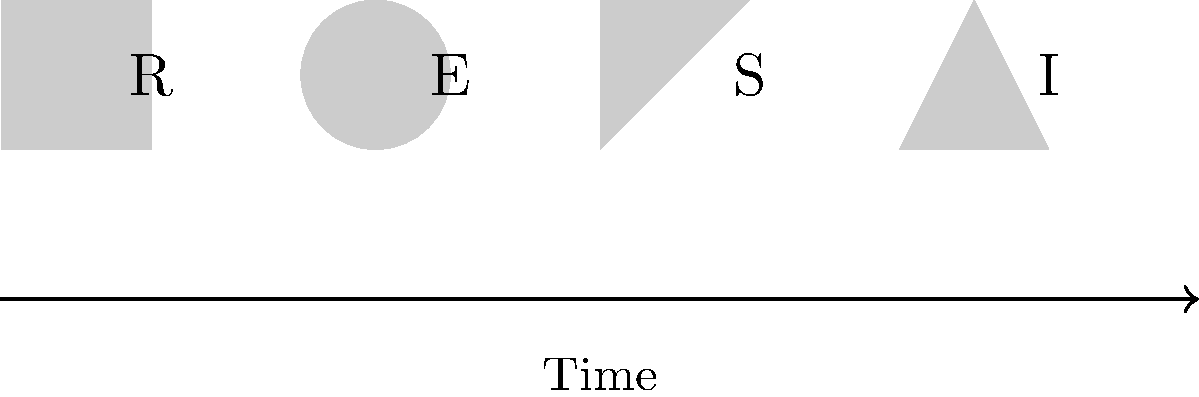Decode the secret message hidden in the sequence of symbols. What word does it spell? To decode the secret message, follow these steps:

1. Observe the sequence of symbols from left to right.
2. Each symbol corresponds to a letter shown below it.
3. The symbols represent:
   - Square: R
   - Circle: E
   - Triangle: S
   - Diamond: I
4. The arrow at the bottom indicates the direction to read the symbols (left to right).
5. Reading the letters in order gives: R-E-S-I
6. This sequence of letters spells out the word "RISE"

The word "RISE" is particularly relevant to the context of political dissidence and activism, symbolizing the act of standing up against oppression or injustice.
Answer: RISE 